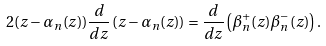<formula> <loc_0><loc_0><loc_500><loc_500>2 ( z - \alpha _ { n } ( z ) ) \frac { d } { d z } \left ( z - \alpha _ { n } ( z ) \right ) = \frac { d } { d z } \left ( \beta ^ { + } _ { n } ( z ) \beta ^ { - } _ { n } ( z ) \right ) .</formula> 